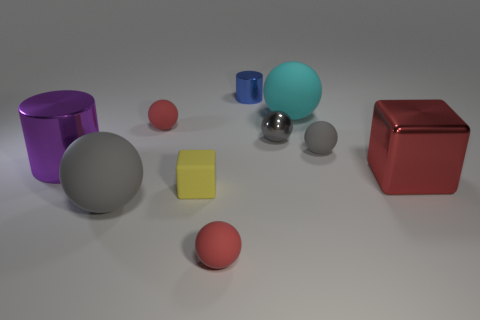What is the material of the blue cylinder?
Keep it short and to the point. Metal. There is a blue metallic thing; how many gray matte objects are right of it?
Provide a short and direct response. 1. Do the gray thing that is on the left side of the small metal ball and the large purple thing have the same material?
Your answer should be compact. No. How many other large things have the same shape as the large cyan object?
Your response must be concise. 1. How many large things are either red cubes or cylinders?
Your answer should be very brief. 2. Does the metal cylinder that is on the left side of the yellow matte thing have the same color as the big shiny cube?
Your answer should be compact. No. There is a large sphere in front of the big purple thing; is it the same color as the large sphere behind the big red metallic cube?
Provide a succinct answer. No. Is there a small blue object made of the same material as the large purple object?
Offer a terse response. Yes. What number of gray objects are either metal things or large rubber things?
Your response must be concise. 2. Are there more large rubber things to the left of the blue metal object than small yellow things?
Keep it short and to the point. No. 